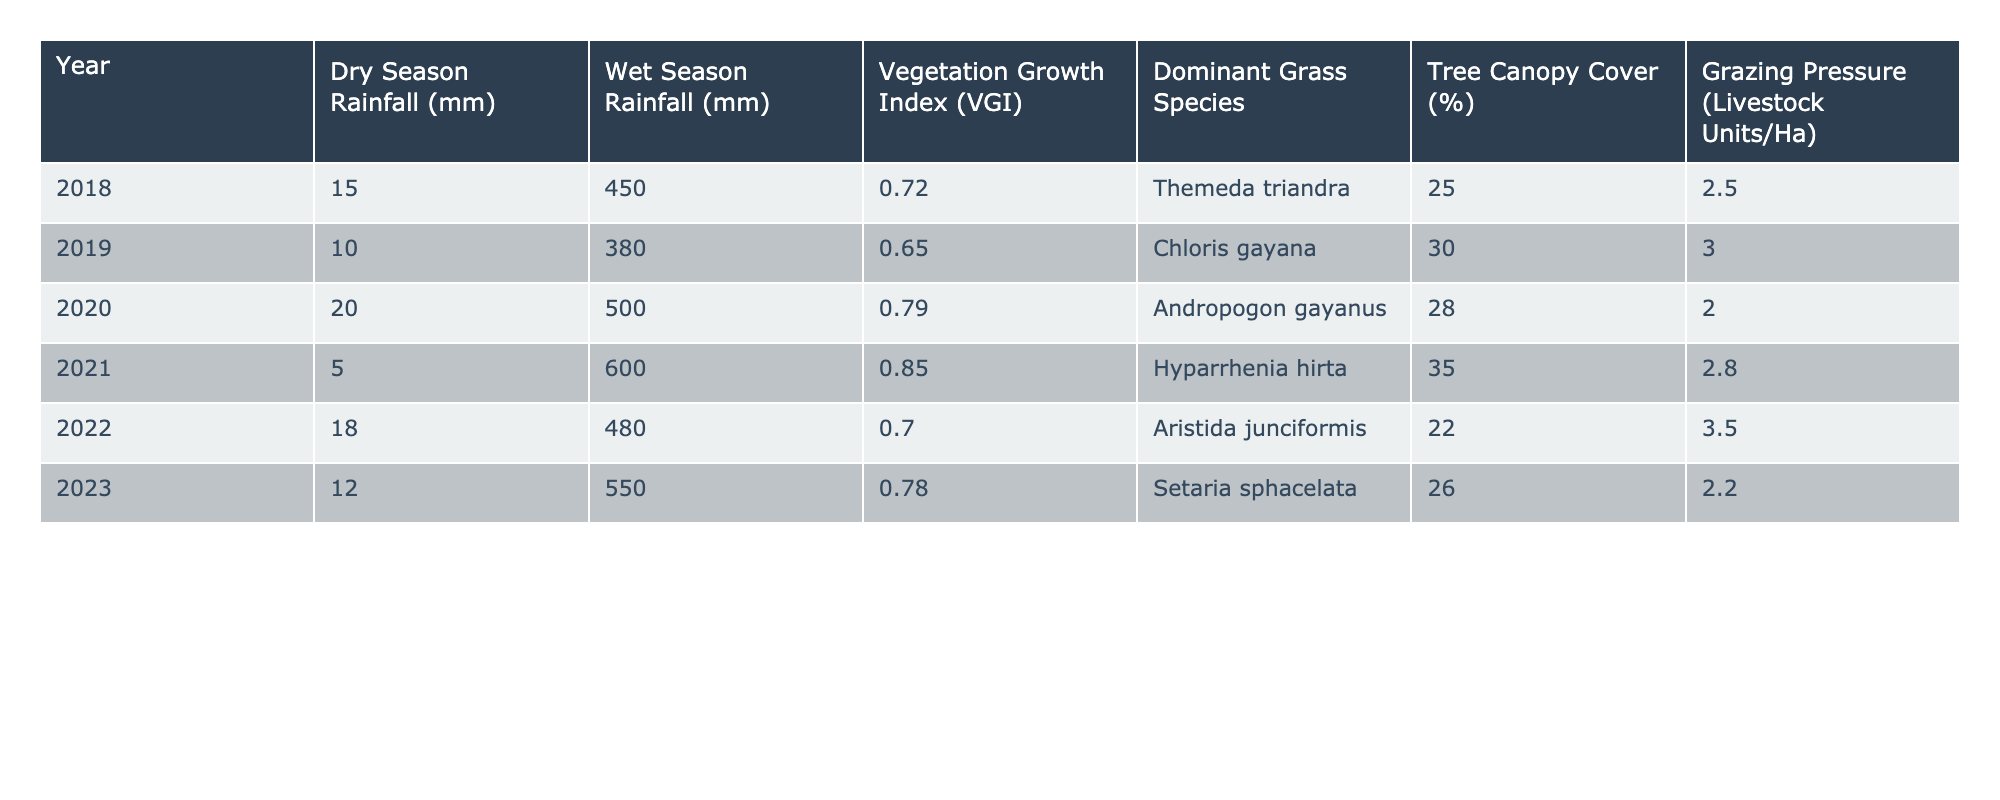What was the highest Vegetation Growth Index recorded in the years documented? The highest Vegetation Growth Index is found in the year 2021, which has a VGI of 0.85.
Answer: 0.85 Which year had the lowest Dry Season Rainfall? The year 2021 had the lowest Dry Season Rainfall, measuring only 5 mm.
Answer: 5 mm What is the average Wet Season Rainfall over the years recorded? Adding the Wet Season Rainfall totals: (450 + 380 + 500 + 600 + 480 + 550) = 2960 mm. Dividing by 6 years gives an average of 2960/6 = 493.33 mm.
Answer: 493.33 mm In which year did Andropogon gayanus dominate, and what was its Vegetation Growth Index? Andropogon gayanus was dominant in 2020, where the VGI was 0.79.
Answer: 0.79 in 2020 Is there a correlation between Dry Season Rainfall and Grazing Pressure in this data? Analyzing the Dry Season Rainfall and Grazing Pressure values, higher grazing pressures generally correspond with lower Dry Season Rainfall, indicating a potential inverse relationship. However, correlation needs statistical analysis to confirm.
Answer: Yes, an inverse relationship is suggested, but correlation needs further analysis What was the difference in Vegetation Growth Index between the years with the highest and the lowest Dry Season Rainfall? The lowest Dry Season Rainfall was in 2021 (5 mm) with a VGI of 0.85, and the highest Dry Season Rainfall was 20 mm in 2020 with a VGI of 0.79. The difference in VGI is 0.85 - 0.79 = 0.06.
Answer: 0.06 What percentage of tree canopy cover was observed in the year with the highest Wet Season Rainfall? The year 2021 had the highest Wet Season Rainfall of 600 mm, and the tree canopy cover that year was 35%.
Answer: 35% Which dominant grass species was associated with the highest Grazing Pressure? Chloris gayana was dominant in 2019, which had a Grazing Pressure of 3.0 Livestock Units/Ha, the highest in the dataset.
Answer: Chloris gayana in 2019 with 3.0 Livestock Units/Ha Was there a year when the Grazing Pressure was less than 2.5 Livestock Units/Ha? No, all recorded years show Grazing Pressure values above 2.5 Livestock Units/Ha.
Answer: No What trend can be observed in the relationship between Wet Season Rainfall and Vegetation Growth Index over the recorded years? As Wet Season Rainfall increased, the Vegetation Growth Index generally also increased, with some exceptions, indicating a positive trend in moisture fertility affecting vegetation growth.
Answer: Positive trend observed 